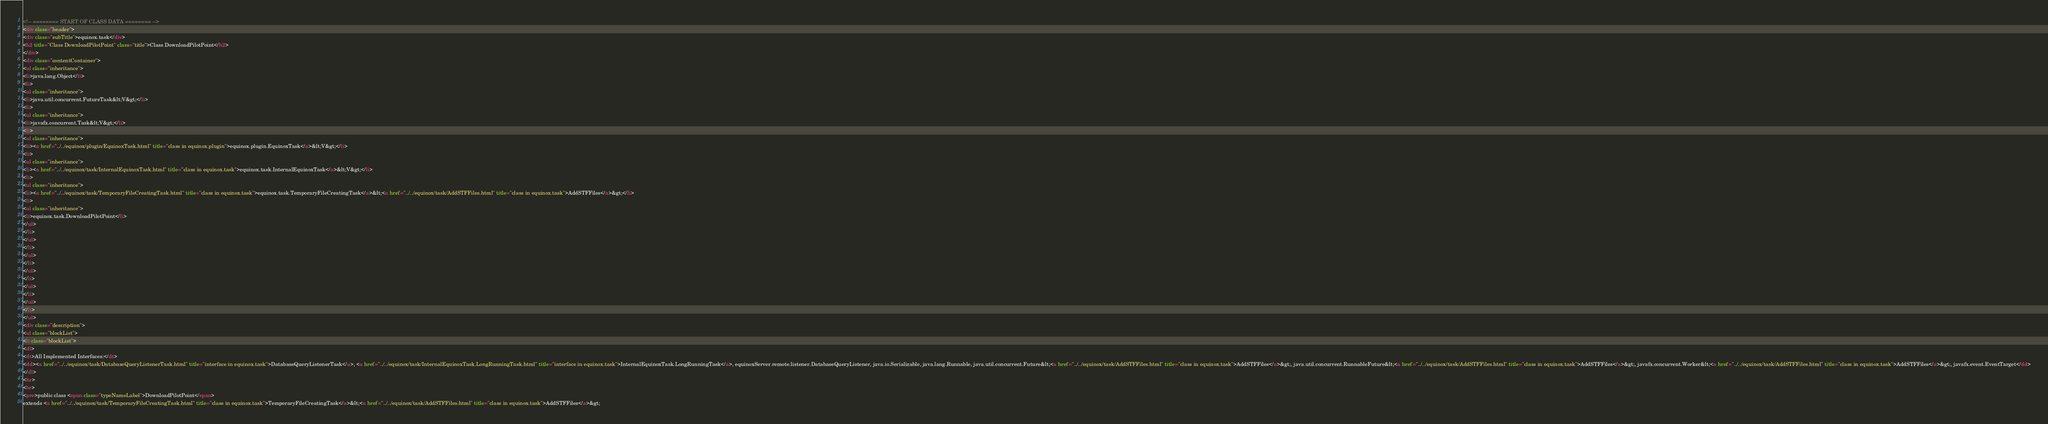Convert code to text. <code><loc_0><loc_0><loc_500><loc_500><_HTML_><!-- ======== START OF CLASS DATA ======== -->
<div class="header">
<div class="subTitle">equinox.task</div>
<h2 title="Class DownloadPilotPoint" class="title">Class DownloadPilotPoint</h2>
</div>
<div class="contentContainer">
<ul class="inheritance">
<li>java.lang.Object</li>
<li>
<ul class="inheritance">
<li>java.util.concurrent.FutureTask&lt;V&gt;</li>
<li>
<ul class="inheritance">
<li>javafx.concurrent.Task&lt;V&gt;</li>
<li>
<ul class="inheritance">
<li><a href="../../equinox/plugin/EquinoxTask.html" title="class in equinox.plugin">equinox.plugin.EquinoxTask</a>&lt;V&gt;</li>
<li>
<ul class="inheritance">
<li><a href="../../equinox/task/InternalEquinoxTask.html" title="class in equinox.task">equinox.task.InternalEquinoxTask</a>&lt;V&gt;</li>
<li>
<ul class="inheritance">
<li><a href="../../equinox/task/TemporaryFileCreatingTask.html" title="class in equinox.task">equinox.task.TemporaryFileCreatingTask</a>&lt;<a href="../../equinox/task/AddSTFFiles.html" title="class in equinox.task">AddSTFFiles</a>&gt;</li>
<li>
<ul class="inheritance">
<li>equinox.task.DownloadPilotPoint</li>
</ul>
</li>
</ul>
</li>
</ul>
</li>
</ul>
</li>
</ul>
</li>
</ul>
</li>
</ul>
<div class="description">
<ul class="blockList">
<li class="blockList">
<dl>
<dt>All Implemented Interfaces:</dt>
<dd><a href="../../equinox/task/DatabaseQueryListenerTask.html" title="interface in equinox.task">DatabaseQueryListenerTask</a>, <a href="../../equinox/task/InternalEquinoxTask.LongRunningTask.html" title="interface in equinox.task">InternalEquinoxTask.LongRunningTask</a>, equinoxServer.remote.listener.DatabaseQueryListener, java.io.Serializable, java.lang.Runnable, java.util.concurrent.Future&lt;<a href="../../equinox/task/AddSTFFiles.html" title="class in equinox.task">AddSTFFiles</a>&gt;, java.util.concurrent.RunnableFuture&lt;<a href="../../equinox/task/AddSTFFiles.html" title="class in equinox.task">AddSTFFiles</a>&gt;, javafx.concurrent.Worker&lt;<a href="../../equinox/task/AddSTFFiles.html" title="class in equinox.task">AddSTFFiles</a>&gt;, javafx.event.EventTarget</dd>
</dl>
<hr>
<br>
<pre>public class <span class="typeNameLabel">DownloadPilotPoint</span>
extends <a href="../../equinox/task/TemporaryFileCreatingTask.html" title="class in equinox.task">TemporaryFileCreatingTask</a>&lt;<a href="../../equinox/task/AddSTFFiles.html" title="class in equinox.task">AddSTFFiles</a>&gt;</code> 